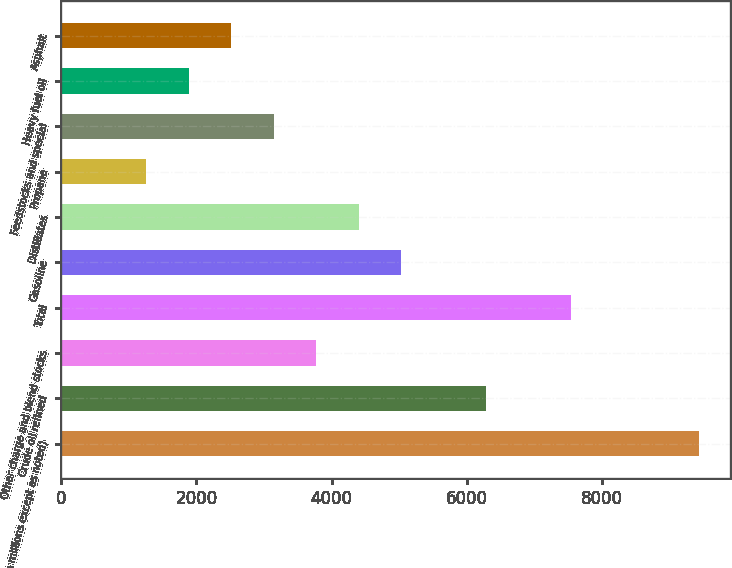<chart> <loc_0><loc_0><loc_500><loc_500><bar_chart><fcel>(In millions except as noted)<fcel>Crude oil refined<fcel>Other charge and blend stocks<fcel>Total<fcel>Gasoline<fcel>Distillates<fcel>Propane<fcel>Feedstocks and special<fcel>Heavy fuel oil<fcel>Asphalt<nl><fcel>9427.47<fcel>6285.02<fcel>3771.06<fcel>7542<fcel>5028.04<fcel>4399.55<fcel>1257.1<fcel>3142.57<fcel>1885.59<fcel>2514.08<nl></chart> 